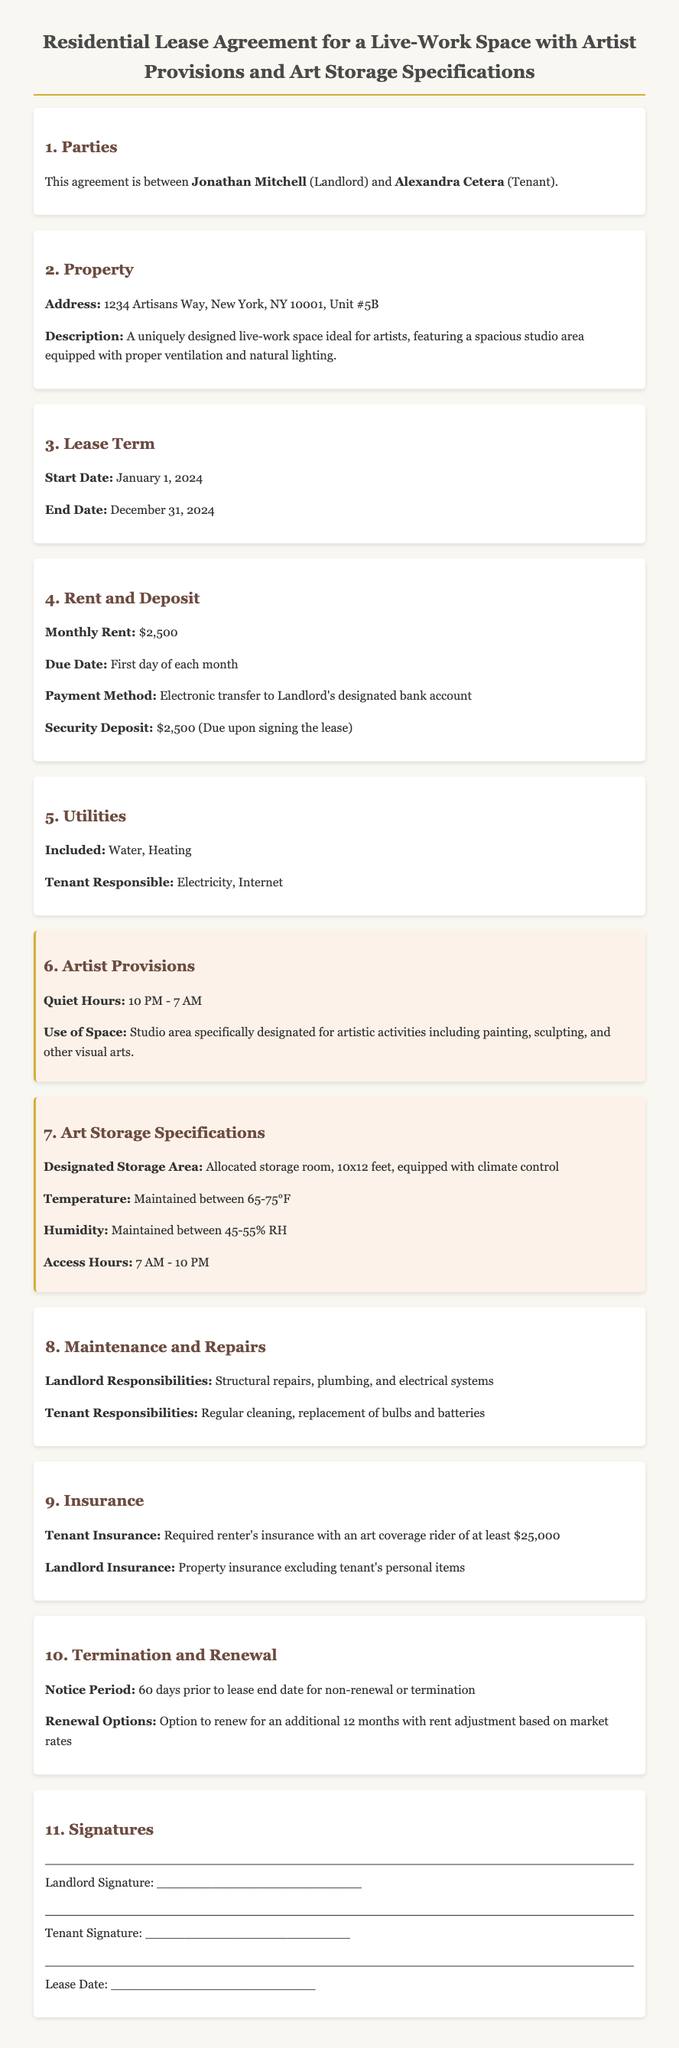What is the address of the property? The address can be found in the Property section, detailing the location of the live-work space.
Answer: 1234 Artisans Way, New York, NY 10001, Unit #5B Who is the landlord? The landlord's name is specified in the Parties section of the lease agreement.
Answer: Jonathan Mitchell What is the monthly rent amount? The monthly rent amount is stated under the Rent and Deposit section of the agreement.
Answer: $2,500 What are the quiet hours? The quiet hours are noted in the Artist Provisions section and specify when noise restrictions apply.
Answer: 10 PM - 7 AM What is the required temperature for the art storage area? The required temperature can be found in the Art Storage Specifications section, indicating environmental controls.
Answer: 65-75°F What is the notice period for lease termination? The notice period for lease termination is mentioned in the Termination and Renewal section.
Answer: 60 days What type of insurance is required for the tenant? The insurance requirements for the tenant are outlined in the Insurance section of the document.
Answer: Renter's insurance with an art coverage rider of at least $25,000 How long is the lease term? The lease term can be found in the Lease Term section specifying the duration of the agreement.
Answer: 12 months 